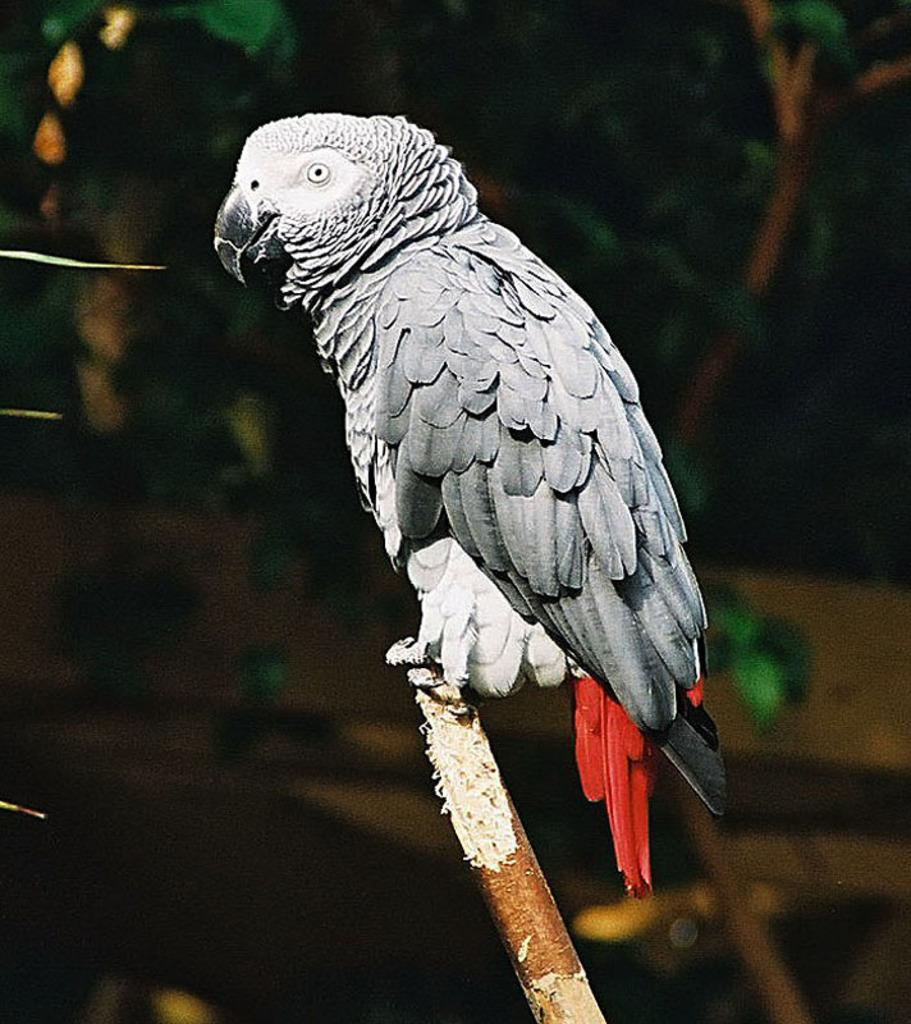What type of animal is in the image? There is a grey parrot in the image. Can you describe the background of the image? The background of the image is blurred. What type of balls does the grey parrot have in its possession in the image? There are no balls present in the image; it features a grey parrot and a blurred background. What type of authority does the grey parrot have in the image? The grey parrot is an animal and does not have any authority in the image. 